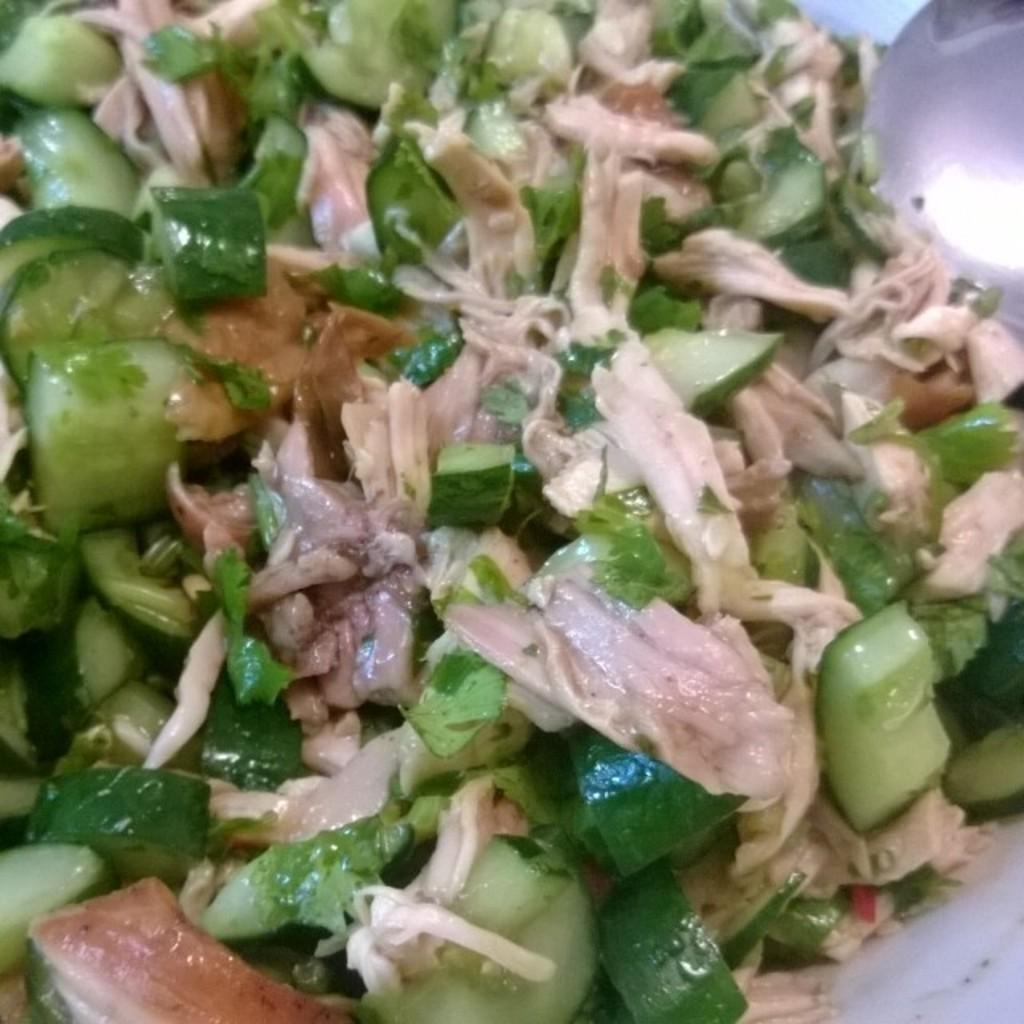What is the main subject of the image? There is a food item on a plate in the image. Can you describe the food item? Unfortunately, the specific type of food item cannot be determined from the provided facts. What is the food item placed on? The food item is placed on a plate. What type of comb is being used to style the food item in the image? There is no comb present in the image, and the food item is not being styled. 